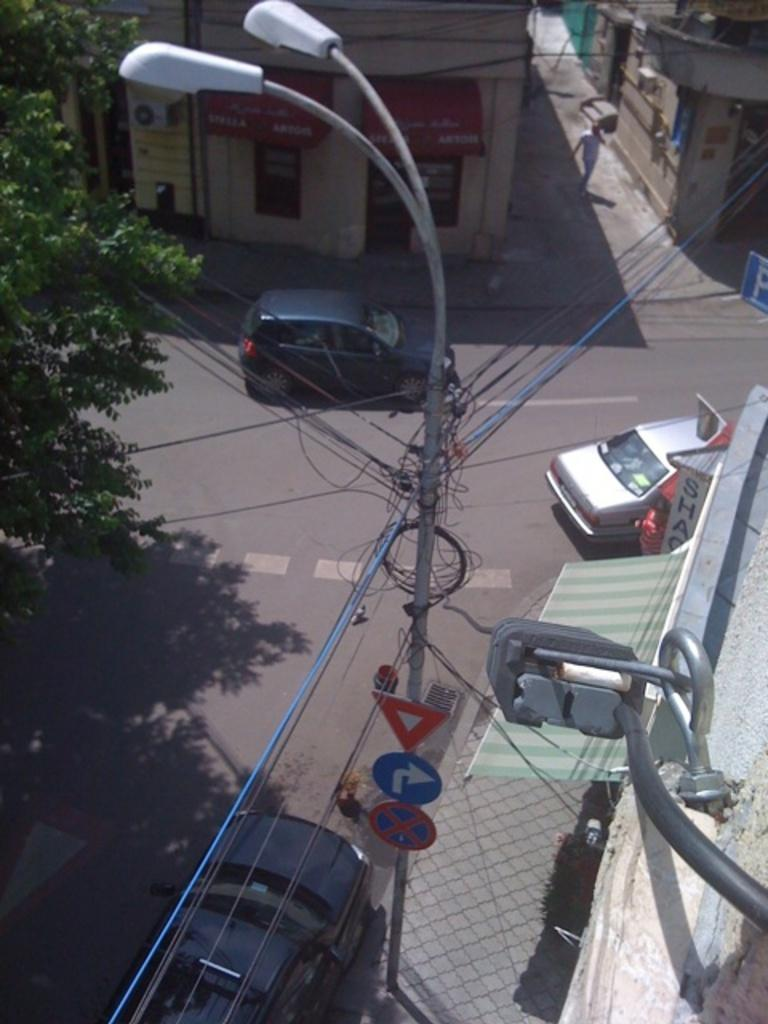What type of structures can be seen in the image? There are poles, cars, trees, and buildings in the image. Can you describe the environment in the image? The image features a mix of natural elements, such as trees, and man-made structures, like poles, cars, and buildings. Is there any sign of human presence in the image? Yes, there is a person in the image. What is the dad discussing with the person in the image? There is no dad present in the image, and therefore no discussion can be observed. How does the motion of the cars affect the person in the image? The image does not show any motion of the cars, and the person's actions or emotions cannot be determined based on the provided facts. 